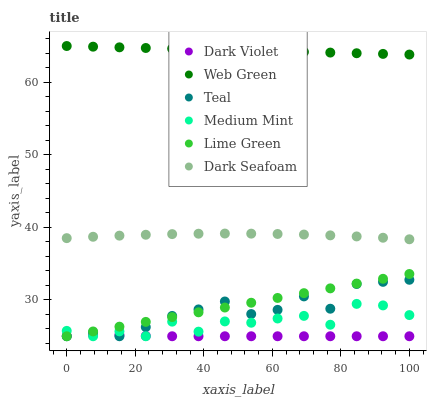Does Dark Violet have the minimum area under the curve?
Answer yes or no. Yes. Does Web Green have the maximum area under the curve?
Answer yes or no. Yes. Does Dark Seafoam have the minimum area under the curve?
Answer yes or no. No. Does Dark Seafoam have the maximum area under the curve?
Answer yes or no. No. Is Lime Green the smoothest?
Answer yes or no. Yes. Is Medium Mint the roughest?
Answer yes or no. Yes. Is Web Green the smoothest?
Answer yes or no. No. Is Web Green the roughest?
Answer yes or no. No. Does Medium Mint have the lowest value?
Answer yes or no. Yes. Does Dark Seafoam have the lowest value?
Answer yes or no. No. Does Web Green have the highest value?
Answer yes or no. Yes. Does Dark Seafoam have the highest value?
Answer yes or no. No. Is Dark Violet less than Web Green?
Answer yes or no. Yes. Is Web Green greater than Teal?
Answer yes or no. Yes. Does Medium Mint intersect Teal?
Answer yes or no. Yes. Is Medium Mint less than Teal?
Answer yes or no. No. Is Medium Mint greater than Teal?
Answer yes or no. No. Does Dark Violet intersect Web Green?
Answer yes or no. No. 